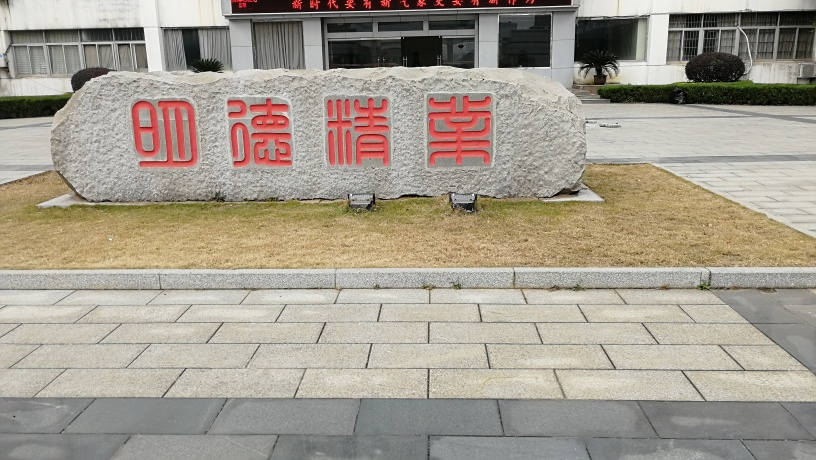What is the lighting like in the image? The lighting in the image is strong and clear, suggesting that the photo was taken during daytime under what appears to be a cloudless sky. The shadows cast by the objects in the image are short and sharp, indicating the sun is high in the sky, around midday. 